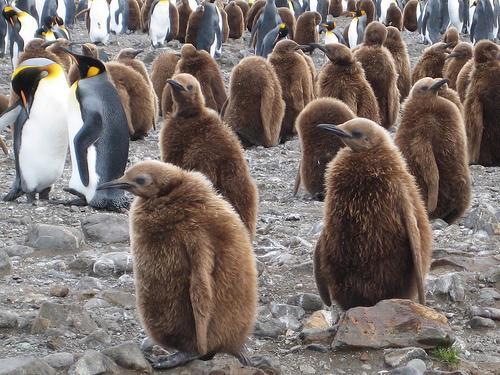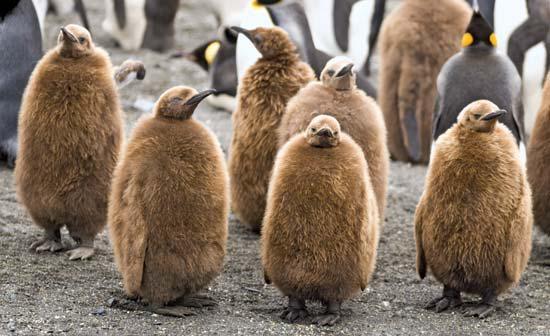The first image is the image on the left, the second image is the image on the right. Evaluate the accuracy of this statement regarding the images: "A hilly landform is behind some of the penguins.". Is it true? Answer yes or no. No. The first image is the image on the left, the second image is the image on the right. Given the left and right images, does the statement "Just one black and white penguin is visible in one image." hold true? Answer yes or no. No. 